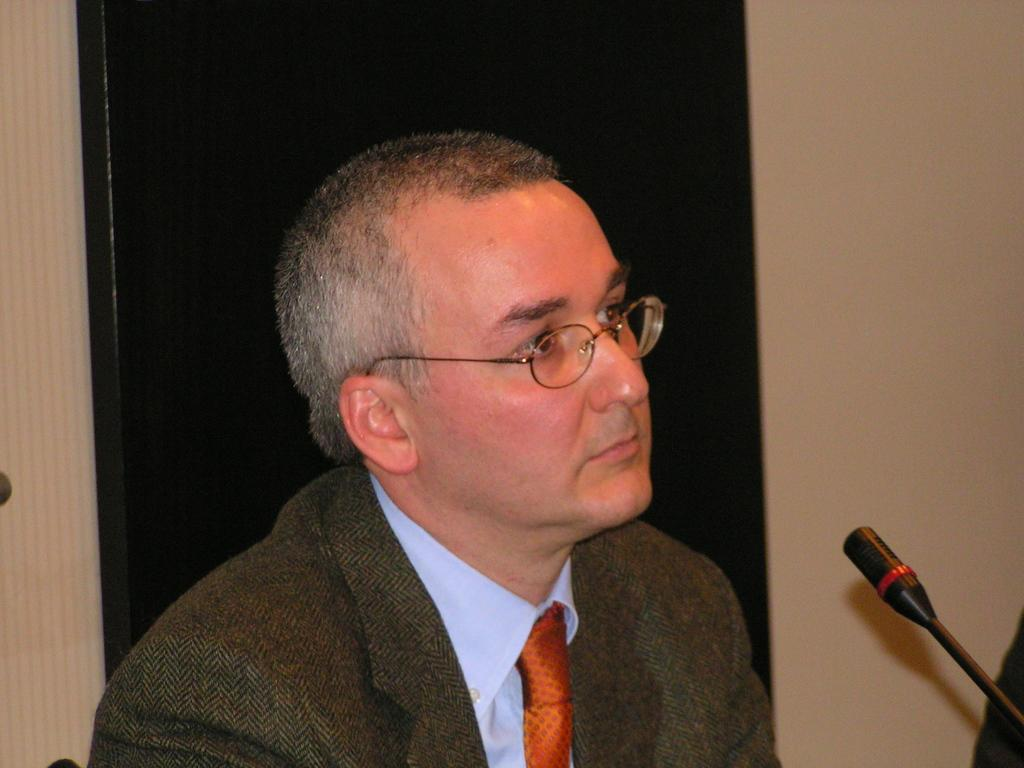What is the main subject of the image? There is a person in the image. What is the person wearing on their upper body? The person is wearing a brown blazer, a white shirt, and a red tie. What object is in front of the person? There is a microphone in front of the person. Can you describe the background of the image? The background of the image includes a wall with black and cream colors. What type of coach can be seen in the image? There is no coach present in the image. Is the stove visible in the image? There is no stove present in the image. 